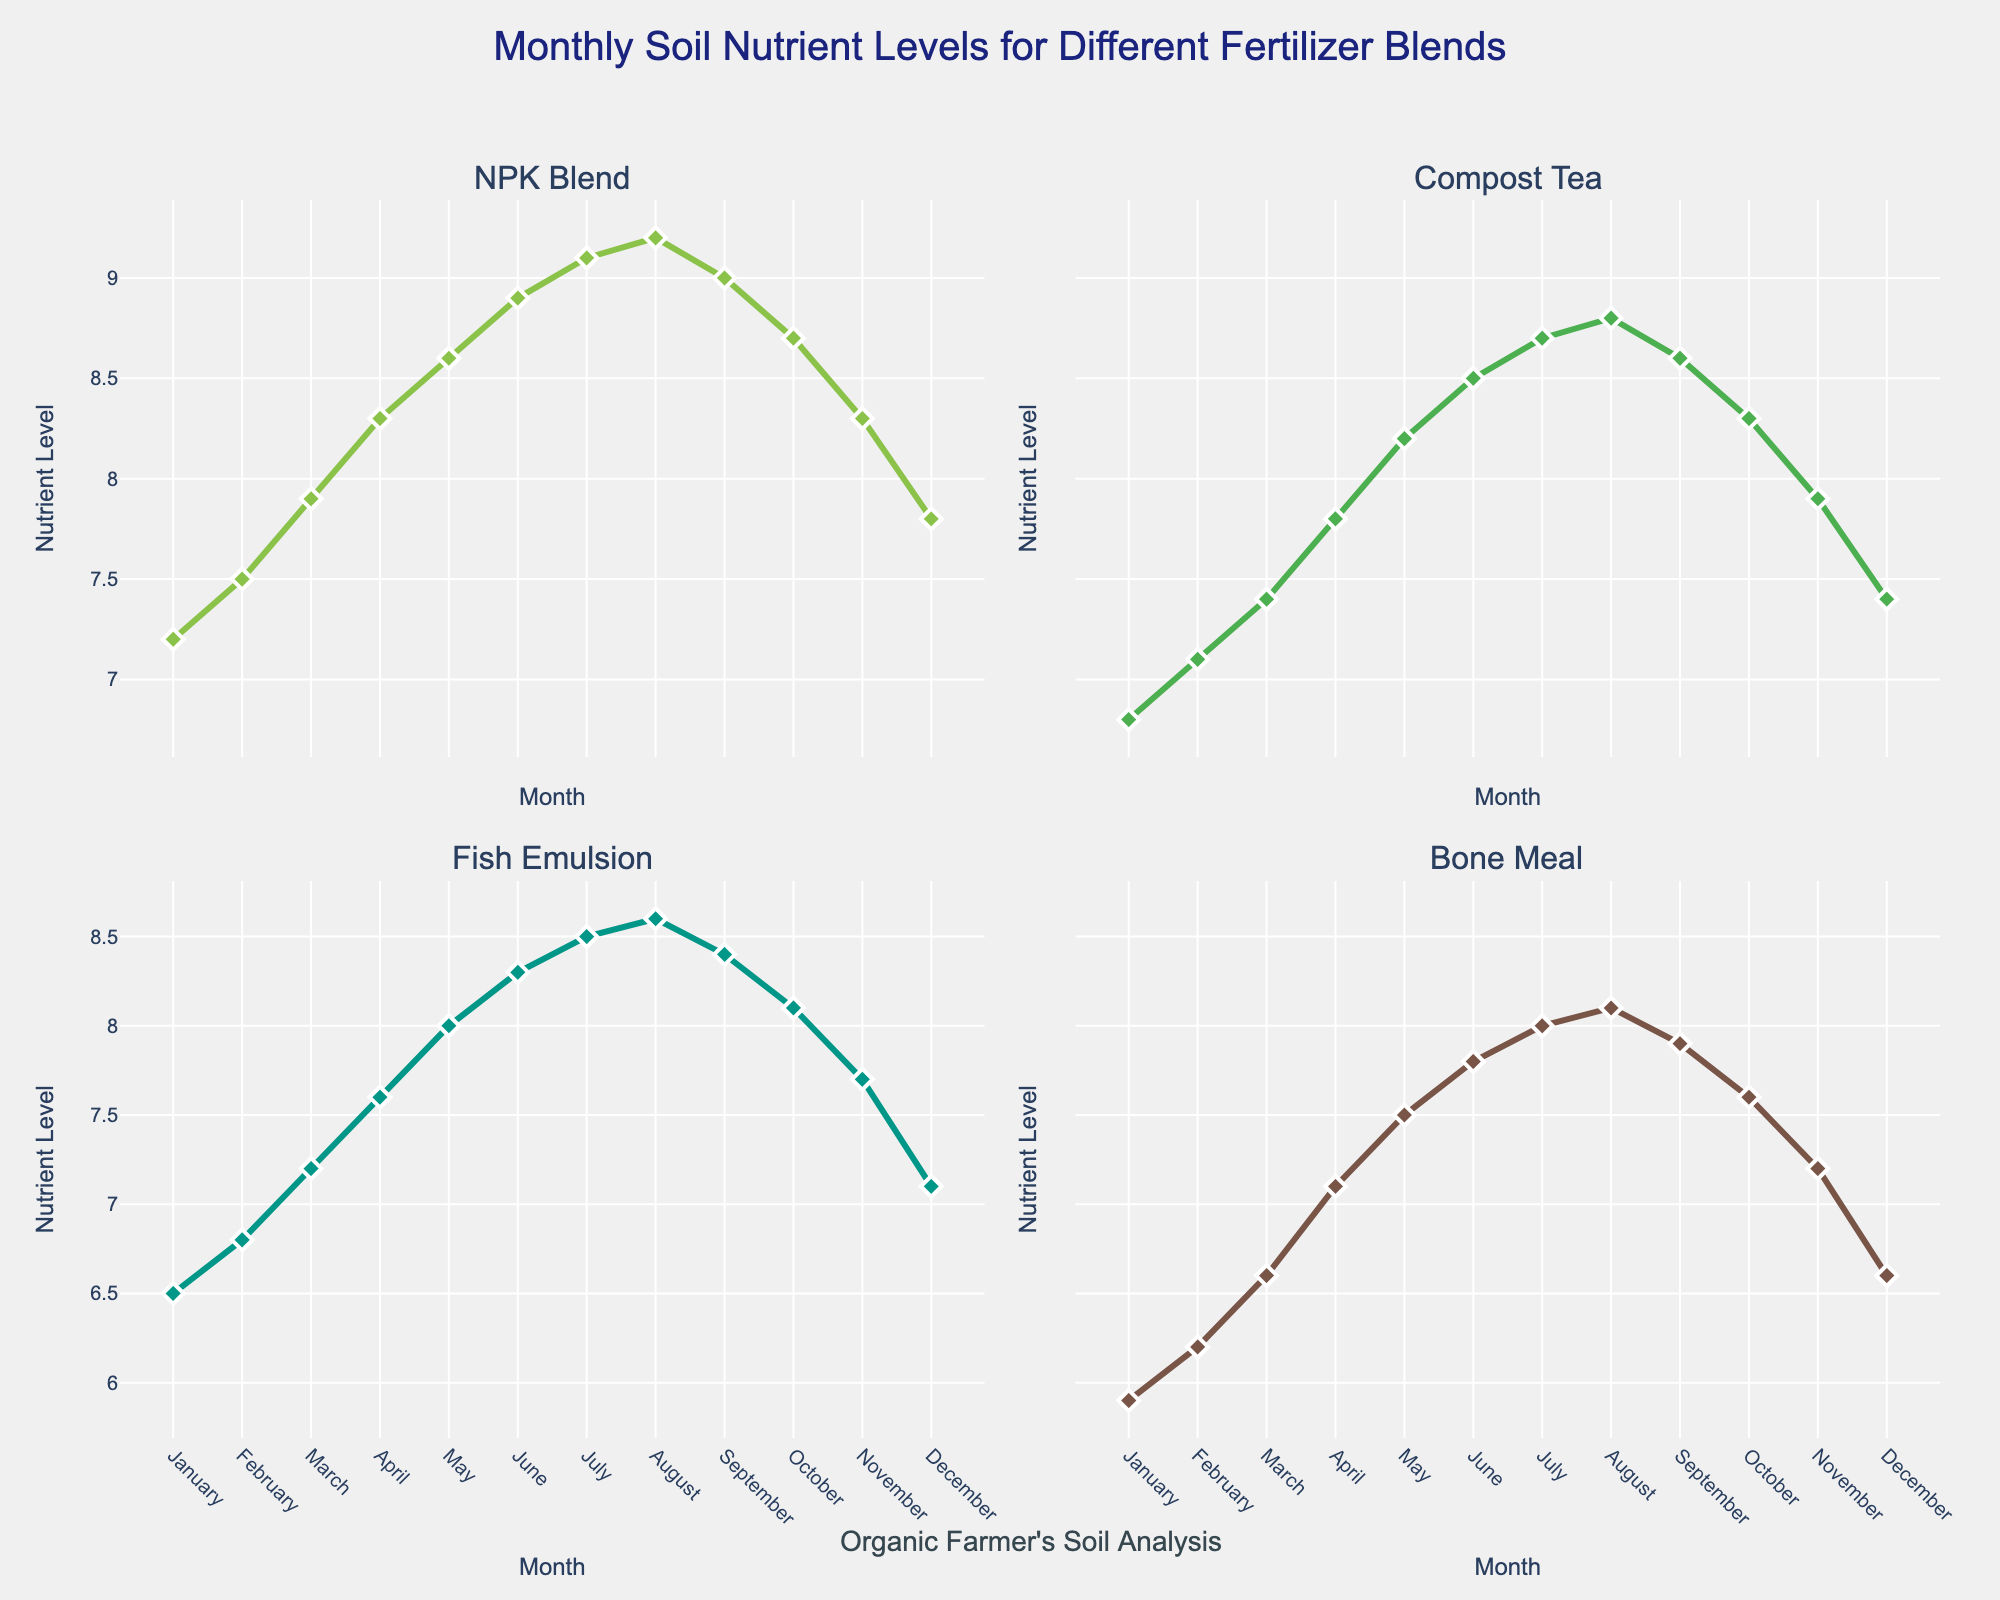Which fertilizer has the highest nutrient level in August? To find the fertilizer with the highest nutrient level in August, examine the subplot for August and compare the levels. NPK Blend shows a level of 9.2, Compost Tea is at 8.8, Fish Emulsion at 8.6, and Bone Meal at 8.1.
Answer: NPK Blend What is the pattern of nutrient levels over the months for Compost Tea? Look at the subplot for Compost Tea which shows nutrient levels increasing from January (6.8) to July (8.7), peaking in August (8.8), and then declining back to 7.4 by December.
Answer: Rising till August, then falling How do the nutrient levels of Fish Emulsion in May compare to those in September? Check the subplot for Fish Emulsion. In May, the nutrient level is 8.0, while in September it is 8.4.
Answer: Higher in September Which month shows the lowest nutrient levels for Bone Meal? To find this, look at the Bone Meal subplot, where January shows the lowest level at 5.9.
Answer: January What is the overall range of nutrient levels for NPK Blend throughout the year? Look at the subplot for NPK Blend. The lowest level is 7.2 in January and the highest level is 9.2 in August. The range is 9.2 - 7.2 = 2.
Answer: 2 Which fertilizer shows the most consistent nutrient levels over the year? To determine consistency, look for the subplot with the least fluctuation in values. Bone Meal has nutrient levels ranging from 5.9 to 8.1, showing the smallest range.
Answer: Bone Meal What is the difference in nutrient levels for NPK Blend between January and July? Check NPK Blend's subplot. In January, the level is 7.2 and in July it is 9.1. The difference is 9.1 - 7.2 = 1.9.
Answer: 1.9 Identify the fertilizer with the largest increase in nutrient levels from January to June. To identify this, calculate the increase for each fertilizer: NPK Blend (8.9 - 7.2 = 1.7), Compost Tea (8.5 - 6.8 = 1.7), Fish Emulsion (8.3 - 6.5 = 1.8), Bone Meal (7.8 - 5.9 = 1.9). Bone Meal shows the largest increase.
Answer: Bone Meal What is the average nutrient level for Fish Emulsion from January to December? Calculate the sum of the monthly nutrient levels for Fish Emulsion (6.5 + 6.8 + 7.2 + 7.6 + 8.0 + 8.3 + 8.5 + 8.6 + 8.4 + 8.1 + 7.7 + 7.1 = 93.8) and divide by 12 (93.8 / 12).
Answer: 7.82 